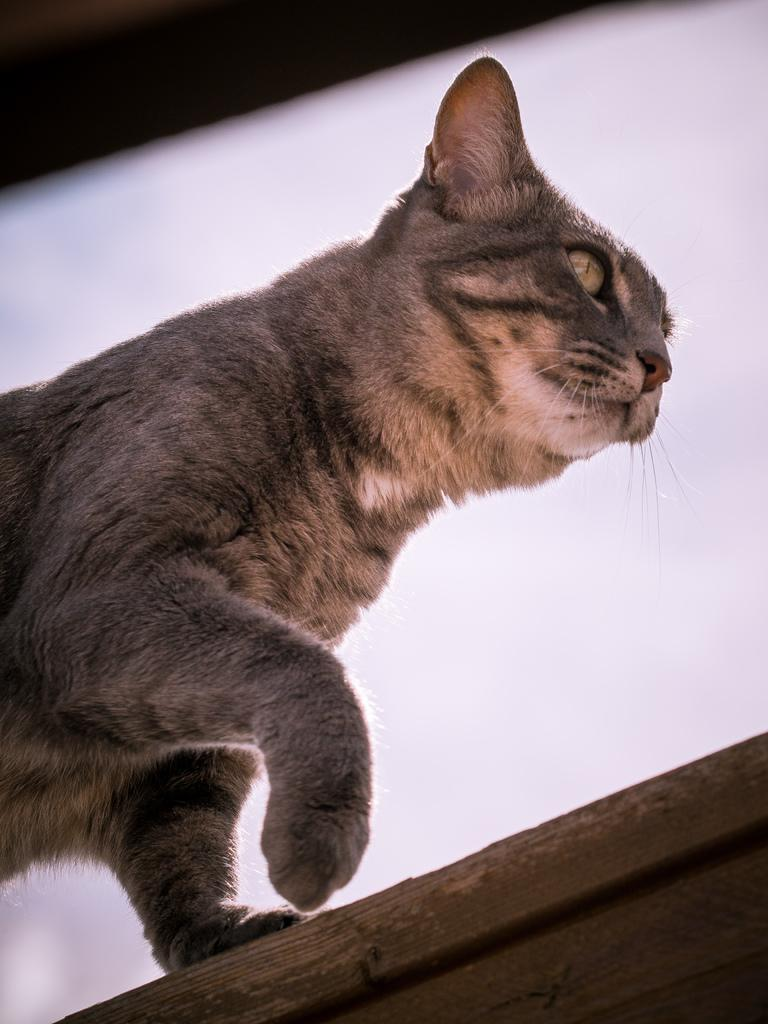What type of animal is in the image? There is a cat in the image. What is the cat standing on? The cat is standing on a wooden surface. What type of yarn is the cat using to increase its wealth in the image? There is no yarn or indication of wealth in the image; it simply features a cat standing on a wooden surface. 